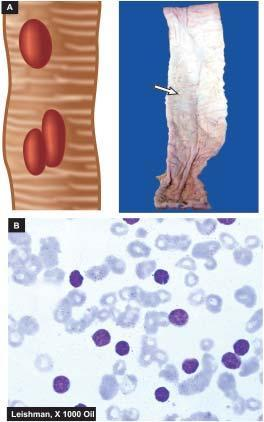what do typhoid ulcers in the small intestine appear characteristically oval with?
Answer the question using a single word or phrase. Their long axis parallel to the long axis of the bowel 